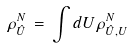Convert formula to latex. <formula><loc_0><loc_0><loc_500><loc_500>\rho ^ { N } _ { \hat { U } } \, = \, \int d U \, \rho ^ { N } _ { \hat { U } , U }</formula> 